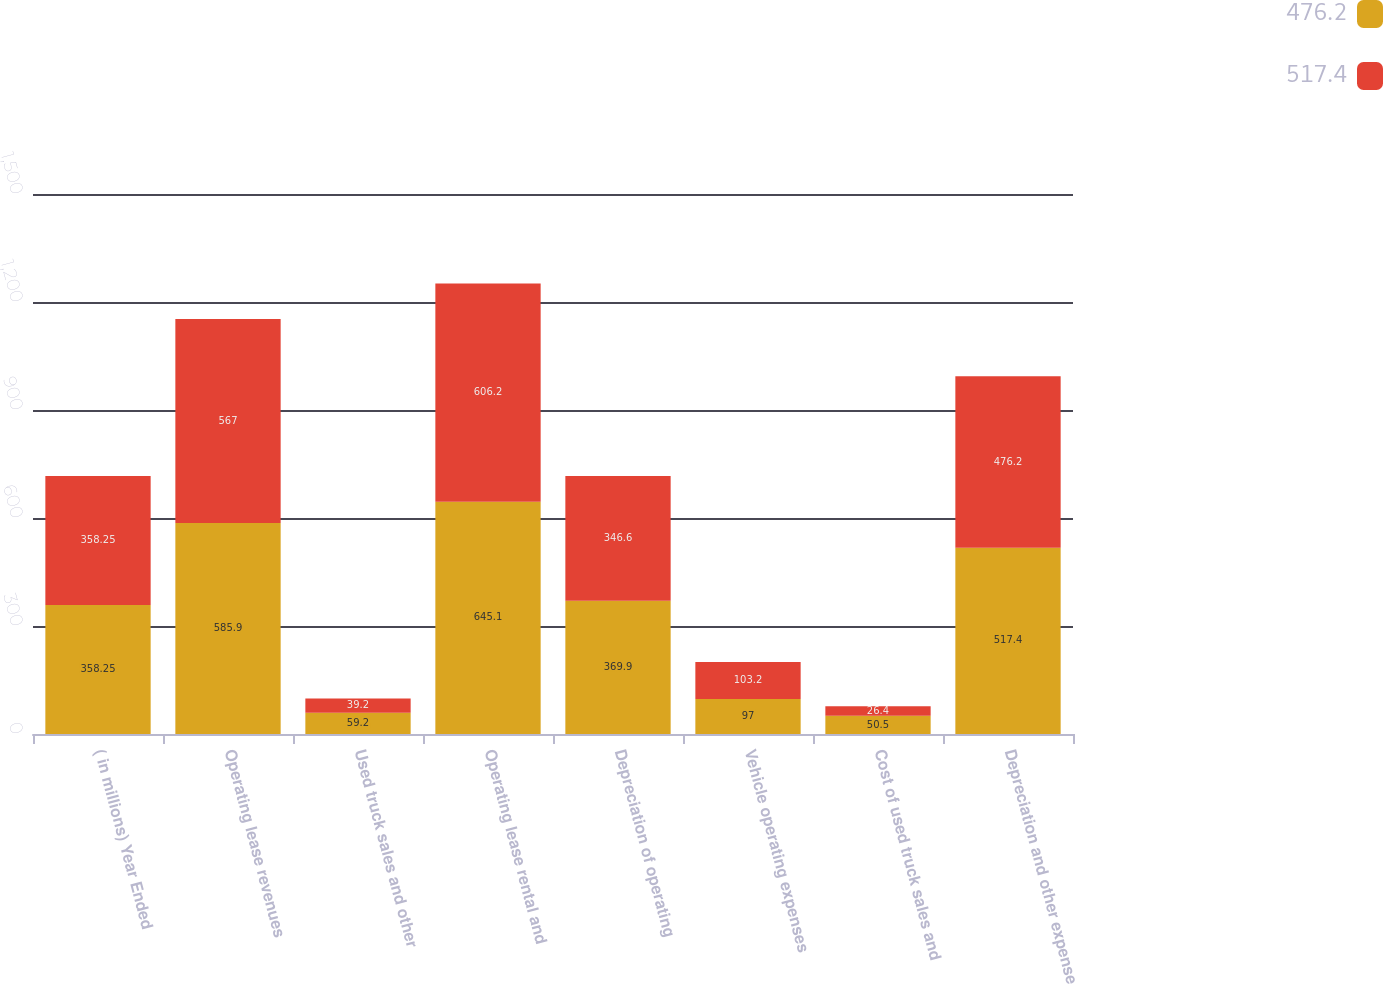Convert chart. <chart><loc_0><loc_0><loc_500><loc_500><stacked_bar_chart><ecel><fcel>( in millions) Year Ended<fcel>Operating lease revenues<fcel>Used truck sales and other<fcel>Operating lease rental and<fcel>Depreciation of operating<fcel>Vehicle operating expenses<fcel>Cost of used truck sales and<fcel>Depreciation and other expense<nl><fcel>476.2<fcel>358.25<fcel>585.9<fcel>59.2<fcel>645.1<fcel>369.9<fcel>97<fcel>50.5<fcel>517.4<nl><fcel>517.4<fcel>358.25<fcel>567<fcel>39.2<fcel>606.2<fcel>346.6<fcel>103.2<fcel>26.4<fcel>476.2<nl></chart> 